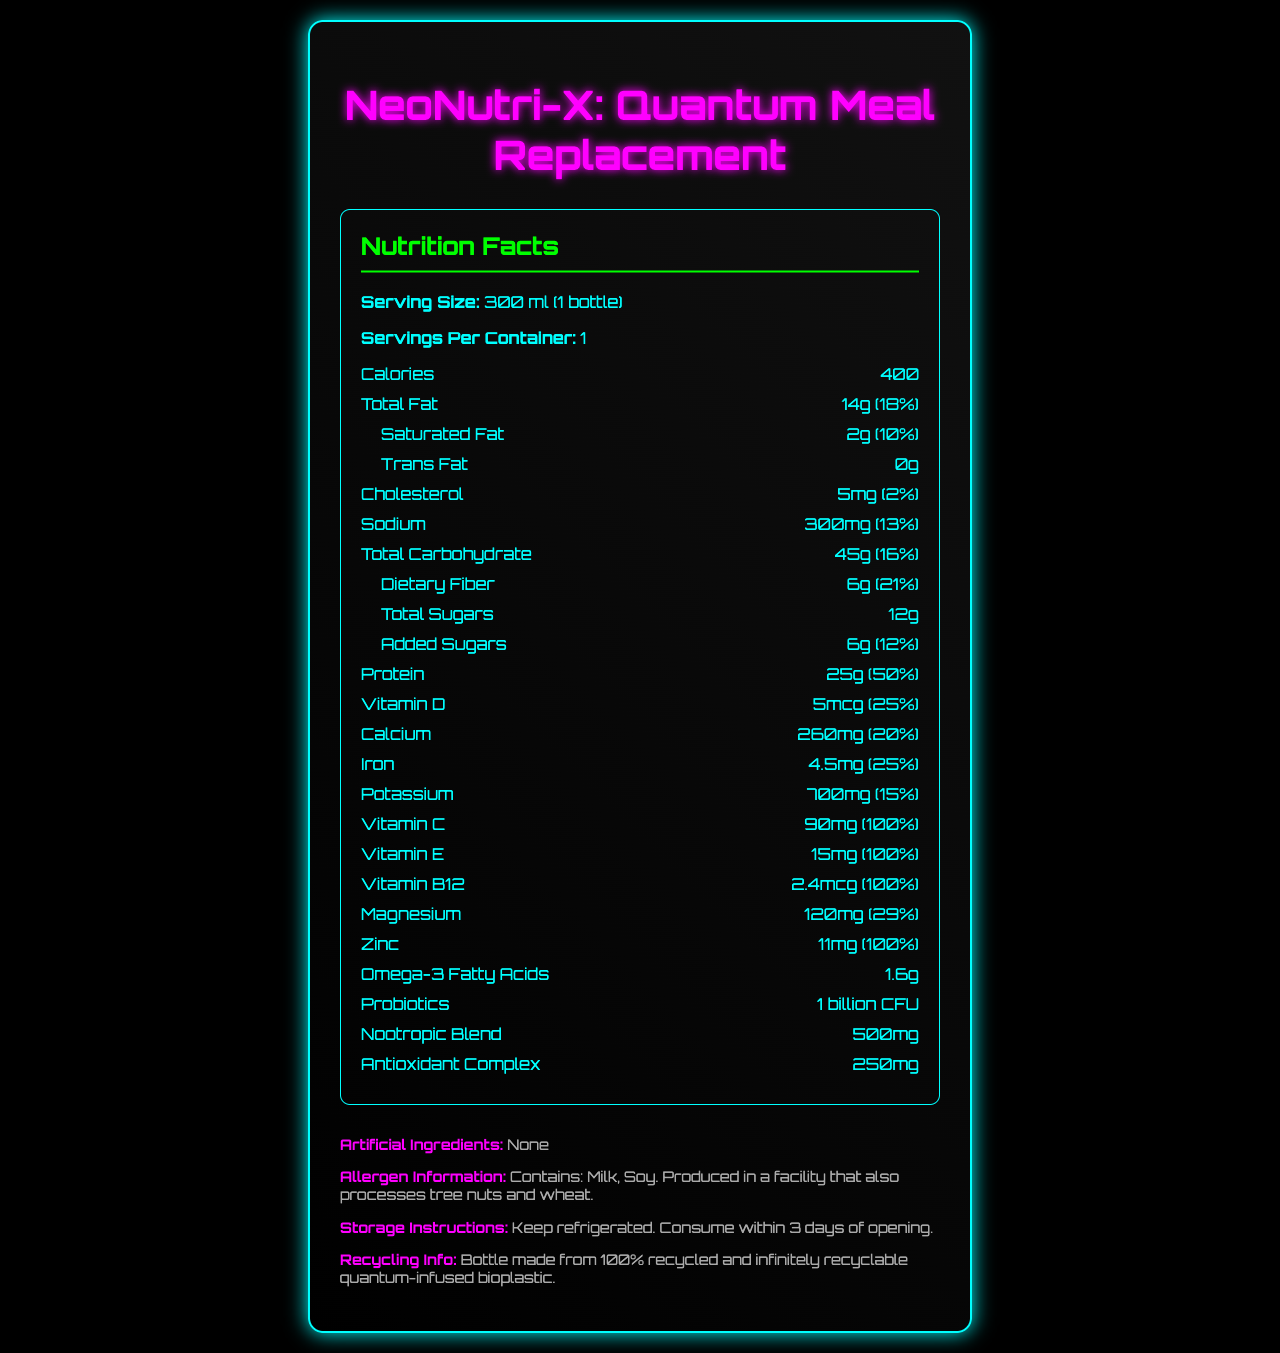what is the serving size of NeoNutri-X: Quantum Meal Replacement? The serving size is specified at the top of the Nutrition Facts section as "300 ml (1 bottle)".
Answer: 300 ml (1 bottle) how many calories does one bottle of NeoNutri-X contain? The calorie content is listed in the Nutrition Facts section next to the word "Calories".
Answer: 400 calories what is the total fat content in NeoNutri-X? The total fat content is shown in the Nutrition Facts section as "Total Fat 14g".
Answer: 14g what are the components of the nootropic blend? The nootropic blend ingredients are listed under the corresponding section in the Nutrition Facts.
Answer: L-theanine, Bacopa monnieri extract, Rhodiola rosea extract what vitamins in NeoNutri-X provide 100% of the daily value? These vitamins are listed with their corresponding daily value percentages in the Nutrition Facts.
Answer: Vitamin C, Vitamin E, Vitamin B12, Zinc how much protein does NeoNutri-X offer per serving? The protein content per serving is shown in the Nutrition Facts section as "Protein 25g".
Answer: 25g which ingredient does NeoNutri-X contain that is related to probiotics? The probiotics content is specified under "Probiotics" in the Nutrition Facts with "1 billion CFU".
Answer: 1 billion CFU what is the percentage daily value of dietary fiber provided by the product? The daily value percentage for dietary fiber is shown in the sub-section under "Total Carbohydrate".
Answer: 21% Identify the allergens in NeoNutri-X from the document. A. Milk B. Eggs C. Soy D. Wheat The allergen information specifies "Contains: Milk, Soy" and additionally mentions production in a facility processing wheat.
Answer: A, C how much calcium is present in one serving of NeoNutri-X? The calcium amount is listed in the Nutrition Facts section as "Calcium 260mg".
Answer: 260mg what makes the bottle of NeoNutri-X special concerning sustainability? The recycling information section specifies that the bottle is made from this special material.
Answer: Made from 100% recycled and infinitely recyclable quantum-infused bioplastic how many milligrams of sodium does NeoNutri-X contain? The sodium content per serving is shown as "Sodium 300mg" in the Nutrition Facts.
Answer: 300mg what is the total carbohydrate content in NeoNutri-X? The total carbohydrate amount is listed in the Nutrition Facts as "Total Carbohydrate 45g".
Answer: 45g does NeoNutri-X contain artificial ingredients? The document specifies "Artificial Ingredients: None" in the additional info section.
Answer: No how should NeoNutri-X be stored? The storage instructions specify these conditions in the additional info section.
Answer: Keep refrigerated. Consume within 3 days of opening. describe the type of fats found in NeoNutri-X along with their amounts. The Nutrition Facts section lists "Total Fat", and under it, "Saturated Fat" and "Trans Fat" with respective amounts.
Answer: Total Fat: 14g, Saturated Fat: 2g, Trans Fat: 0g is NeoNutri-X suitable for someone avoiding cholesterol completely? The Nutrition Facts indicate that NeoNutri-X contains 5mg of cholesterol.
Answer: No is there any information about flavors available for NeoNutri-X? The provided document does not mention any flavor-related information.
Answer: Cannot be determined summarize the nutritional features of NeoNutri-X: Quantum Meal Replacement. NeoNutri-X offers balanced nutrition with notable contents of vitamins C, E, B12, protein, and other micronutrients. It also highlights the use of a recyclable and eco-friendly bottle, catering to modern sustainability needs.
Answer: NeoNutri-X is a high-nutrient meal replacement drink with substantial levels of protein, dietary fiber, vitamins, minerals, and special ingredients like omega-3 and probiotics. It is free from artificial ingredients, specifies allergen information, and is packaged in a sustainable bottle. 